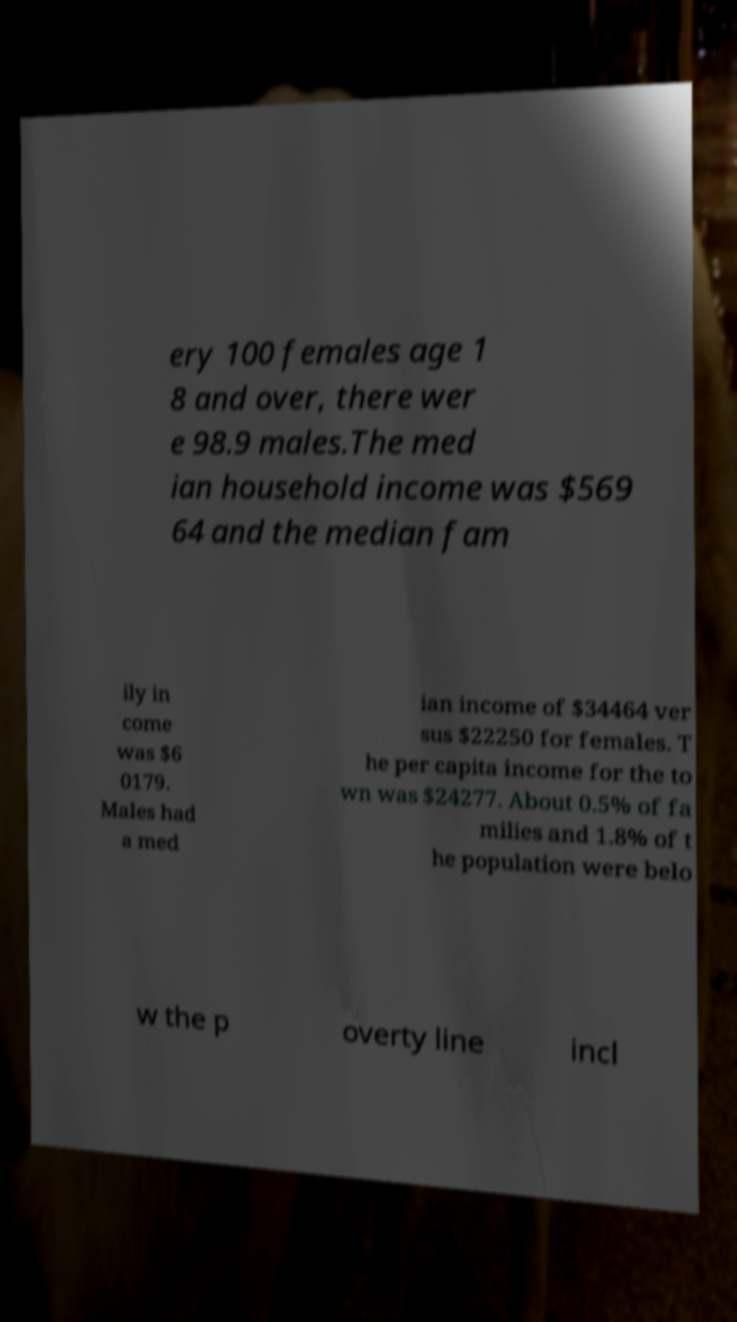Can you accurately transcribe the text from the provided image for me? ery 100 females age 1 8 and over, there wer e 98.9 males.The med ian household income was $569 64 and the median fam ily in come was $6 0179. Males had a med ian income of $34464 ver sus $22250 for females. T he per capita income for the to wn was $24277. About 0.5% of fa milies and 1.8% of t he population were belo w the p overty line incl 